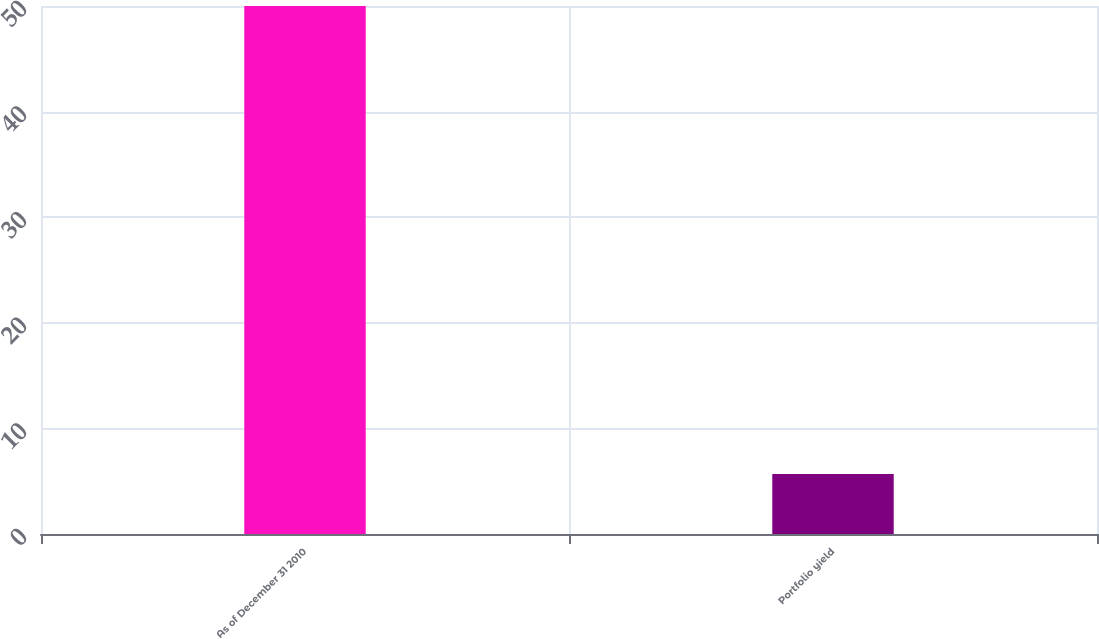Convert chart to OTSL. <chart><loc_0><loc_0><loc_500><loc_500><bar_chart><fcel>As of December 31 2010<fcel>Portfolio yield<nl><fcel>50<fcel>5.69<nl></chart> 